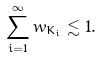<formula> <loc_0><loc_0><loc_500><loc_500>\sum _ { i = 1 } ^ { \infty } w _ { K _ { i } } \lesssim 1 .</formula> 